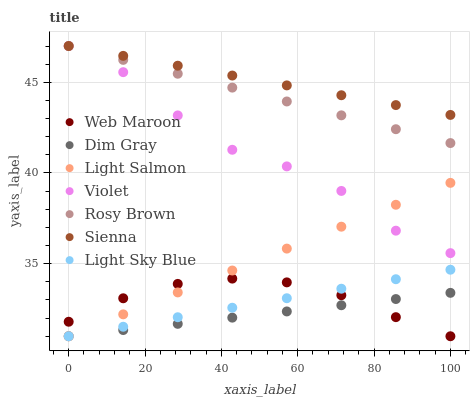Does Dim Gray have the minimum area under the curve?
Answer yes or no. Yes. Does Sienna have the maximum area under the curve?
Answer yes or no. Yes. Does Rosy Brown have the minimum area under the curve?
Answer yes or no. No. Does Rosy Brown have the maximum area under the curve?
Answer yes or no. No. Is Sienna the smoothest?
Answer yes or no. Yes. Is Violet the roughest?
Answer yes or no. Yes. Is Dim Gray the smoothest?
Answer yes or no. No. Is Dim Gray the roughest?
Answer yes or no. No. Does Light Salmon have the lowest value?
Answer yes or no. Yes. Does Rosy Brown have the lowest value?
Answer yes or no. No. Does Violet have the highest value?
Answer yes or no. Yes. Does Dim Gray have the highest value?
Answer yes or no. No. Is Light Salmon less than Rosy Brown?
Answer yes or no. Yes. Is Rosy Brown greater than Dim Gray?
Answer yes or no. Yes. Does Rosy Brown intersect Sienna?
Answer yes or no. Yes. Is Rosy Brown less than Sienna?
Answer yes or no. No. Is Rosy Brown greater than Sienna?
Answer yes or no. No. Does Light Salmon intersect Rosy Brown?
Answer yes or no. No. 